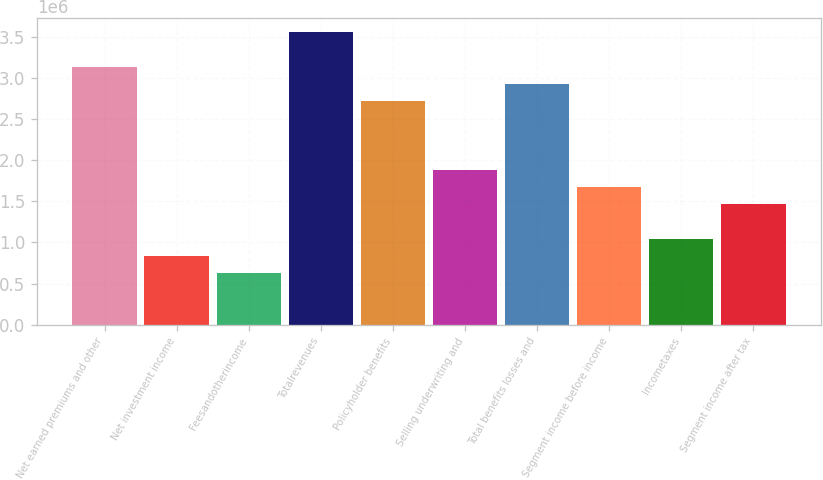Convert chart to OTSL. <chart><loc_0><loc_0><loc_500><loc_500><bar_chart><fcel>Net earned premiums and other<fcel>Net investment income<fcel>Feesandotherincome<fcel>Totalrevenues<fcel>Policyholder benefits<fcel>Selling underwriting and<fcel>Total benefits losses and<fcel>Segment income before income<fcel>Incometaxes<fcel>Segment income after tax<nl><fcel>3.13639e+06<fcel>836391<fcel>627300<fcel>3.55457e+06<fcel>2.7182e+06<fcel>1.88184e+06<fcel>2.92729e+06<fcel>1.67275e+06<fcel>1.04548e+06<fcel>1.46366e+06<nl></chart> 